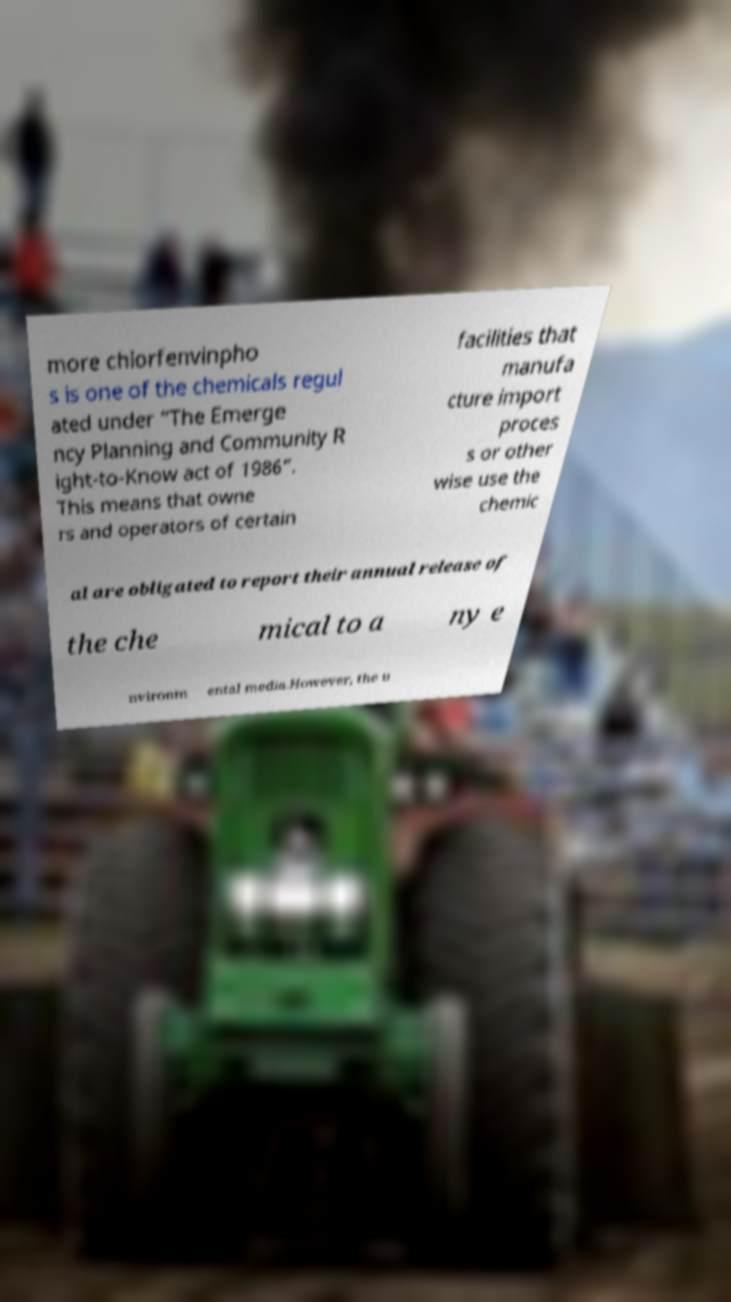For documentation purposes, I need the text within this image transcribed. Could you provide that? more chlorfenvinpho s is one of the chemicals regul ated under “The Emerge ncy Planning and Community R ight-to-Know act of 1986”. This means that owne rs and operators of certain facilities that manufa cture import proces s or other wise use the chemic al are obligated to report their annual release of the che mical to a ny e nvironm ental media.However, the u 